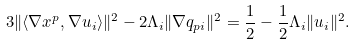<formula> <loc_0><loc_0><loc_500><loc_500>3 \| \langle \nabla x ^ { p } , \nabla u _ { i } \rangle \| ^ { 2 } - 2 \Lambda _ { i } \| \nabla q _ { p i } \| ^ { 2 } = \frac { 1 } { 2 } - \frac { 1 } { 2 } \Lambda _ { i } \| u _ { i } \| ^ { 2 } .</formula> 